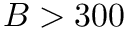Convert formula to latex. <formula><loc_0><loc_0><loc_500><loc_500>B > 3 0 0</formula> 